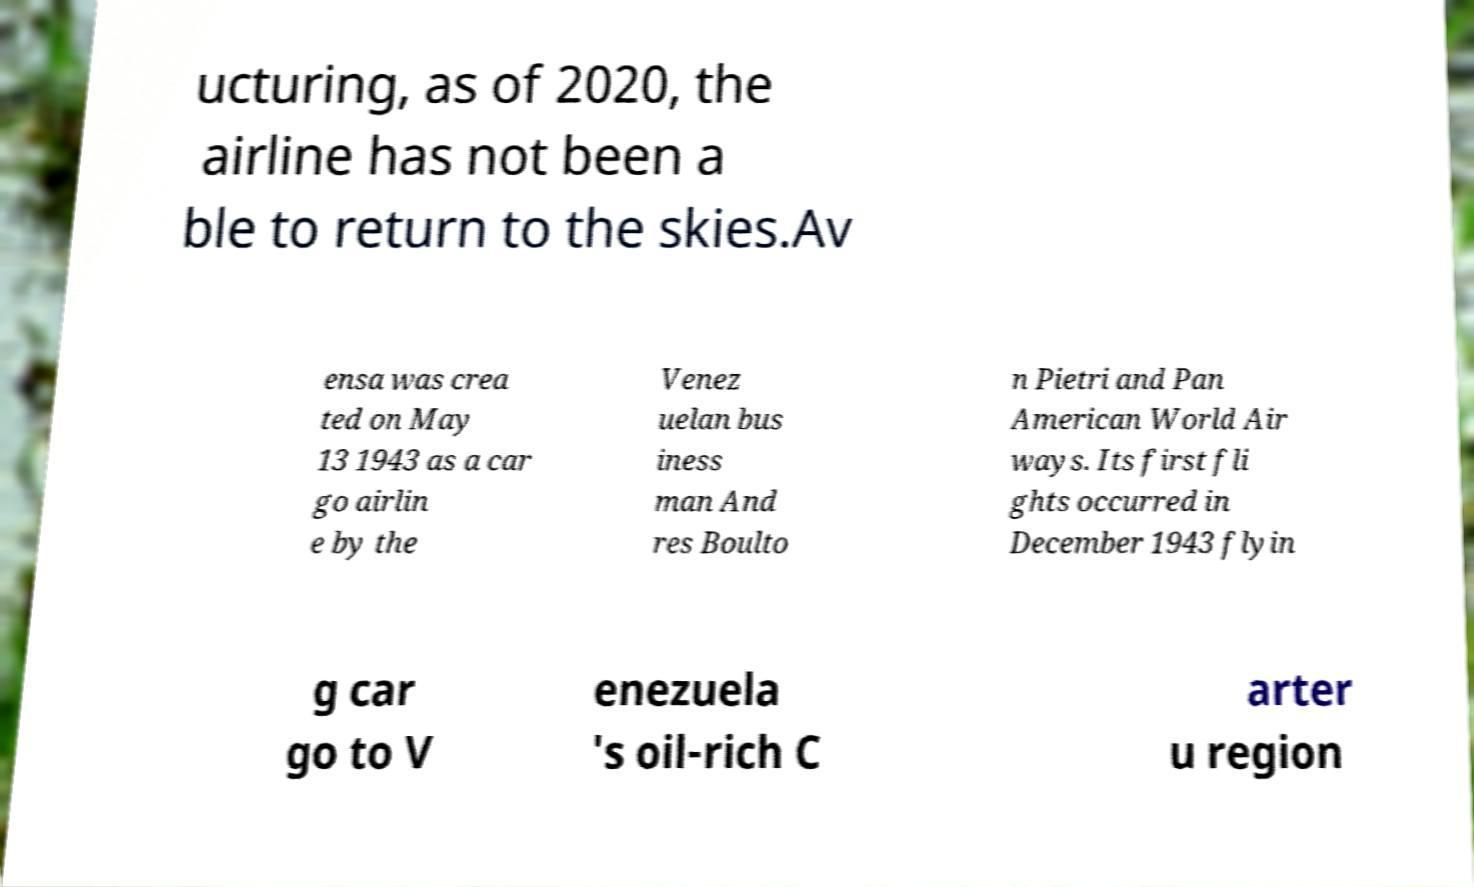What messages or text are displayed in this image? I need them in a readable, typed format. ucturing, as of 2020, the airline has not been a ble to return to the skies.Av ensa was crea ted on May 13 1943 as a car go airlin e by the Venez uelan bus iness man And res Boulto n Pietri and Pan American World Air ways. Its first fli ghts occurred in December 1943 flyin g car go to V enezuela 's oil-rich C arter u region 